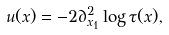<formula> <loc_0><loc_0><loc_500><loc_500>u ( x ) = - 2 \partial _ { x _ { 1 } } ^ { 2 } \log \tau ( x ) ,</formula> 